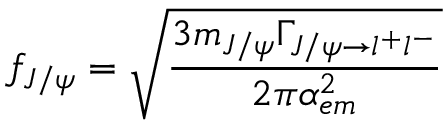Convert formula to latex. <formula><loc_0><loc_0><loc_500><loc_500>f _ { J / \psi } = \sqrt { { \frac { 3 m _ { J / \psi } \Gamma _ { J / \psi \rightarrow l ^ { + } l ^ { - } } } { 2 \pi \alpha _ { e m } ^ { 2 } } } }</formula> 